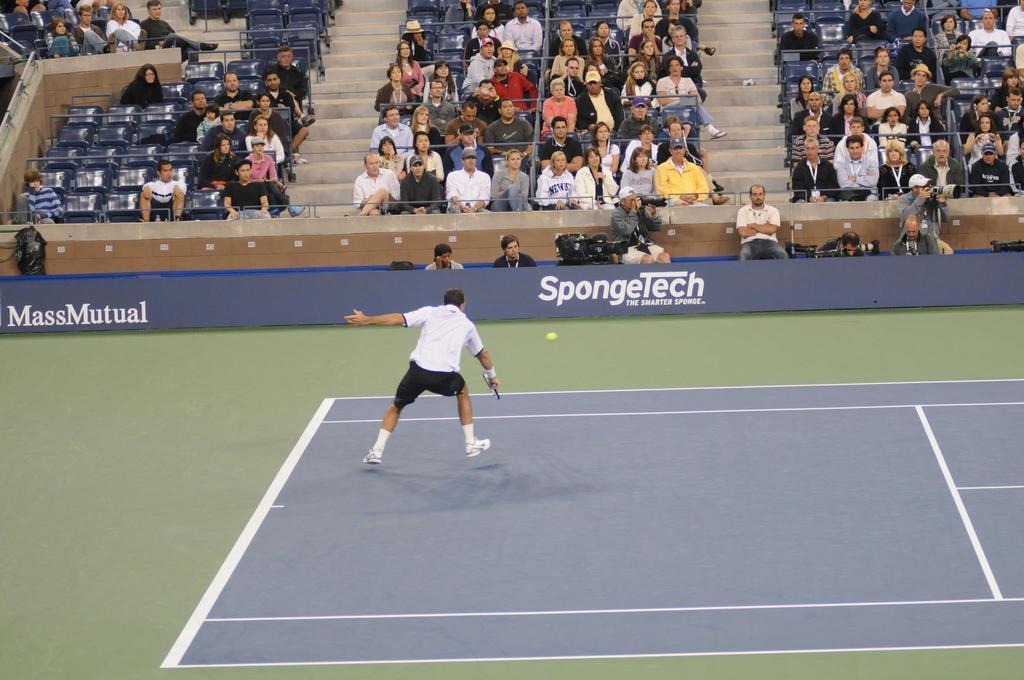Describe this image in one or two sentences. In this picture we can see a man who is playing in the ground. This is the ball. Here we can see some persons are sitting on the chairs. And this is the hoarding. 